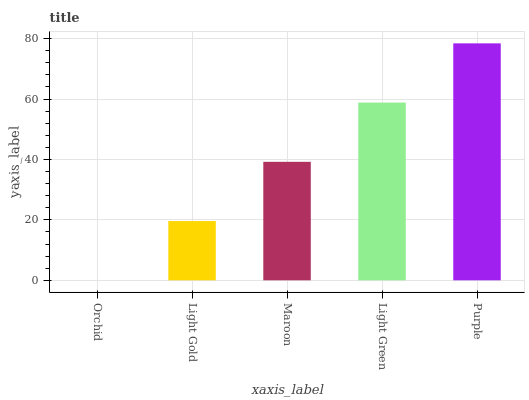Is Orchid the minimum?
Answer yes or no. Yes. Is Purple the maximum?
Answer yes or no. Yes. Is Light Gold the minimum?
Answer yes or no. No. Is Light Gold the maximum?
Answer yes or no. No. Is Light Gold greater than Orchid?
Answer yes or no. Yes. Is Orchid less than Light Gold?
Answer yes or no. Yes. Is Orchid greater than Light Gold?
Answer yes or no. No. Is Light Gold less than Orchid?
Answer yes or no. No. Is Maroon the high median?
Answer yes or no. Yes. Is Maroon the low median?
Answer yes or no. Yes. Is Light Gold the high median?
Answer yes or no. No. Is Orchid the low median?
Answer yes or no. No. 